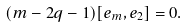<formula> <loc_0><loc_0><loc_500><loc_500>( m - 2 q - 1 ) [ e _ { m } , e _ { 2 } ] = 0 .</formula> 